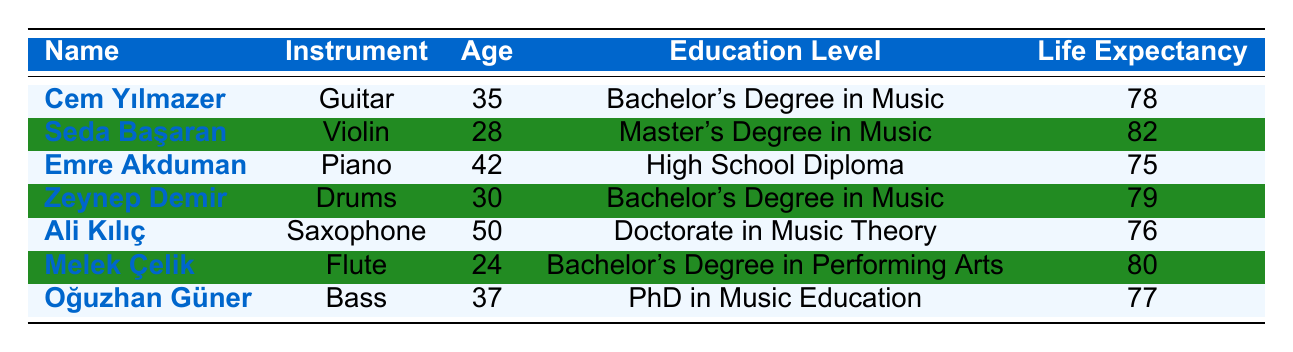What is the life expectancy of Seda Başaran? Seda Başaran has a life expectancy listed in the table. Referring to her row, we see that her life expectancy is 82 years.
Answer: 82 What education level does Emre Akduman have? Emre Akduman's education level can be found in his corresponding row in the table, which states he has a High School Diploma.
Answer: High School Diploma How many musicians have a life expectancy above 78 years? To answer this, we need to look at each musician's life expectancy. The musicians with life expectancies above 78 years are Seda Başaran (82), Zeynep Demir (79), and Melek Çelik (80). Counting these, we find that there are 3 musicians.
Answer: 3 What is the average life expectancy of the musicians listed? To find the average life expectancy, we sum the life expectancies of all musicians: 78 + 82 + 75 + 79 + 76 + 80 + 77 = 527. Then, we divide this total by the number of musicians (7), giving us 527 / 7 = 75.2857, which can be rounded to 75.29.
Answer: 75.29 Is it true that all musicians with a Doctorate have a life expectancy of 80 years or more? The only musician with a Doctorate is Ali Kılıç, who has a life expectancy of 76 years. Therefore, the statement is false since he does not have a life expectancy of 80 years or more.
Answer: No What is the highest education level among the musicians in the table? The highest education level can be identified by comparing the education levels listed for all musicians. The highest level mentioned is "Doctorate in Music Theory" held by Ali Kılıç.
Answer: Doctorate in Music Theory How many musicians are aged over 35 years? We check the ages of all musicians in the table. The musicians above 35 years old are Emre Akduman (42), Ali Kılıç (50), and Oğuzhan Güner (37). Therefore, the total is 3 musicians over 35 years.
Answer: 3 Which musician with a Bachelor’s Degree has the highest life expectancy? We identify those with a Bachelor’s Degree: Cem Yılmazer (78) and Zeynep Demir (79). Comparing their life expectancies, Zeynep Demir has the highest at 79 years.
Answer: Zeynep Demir 